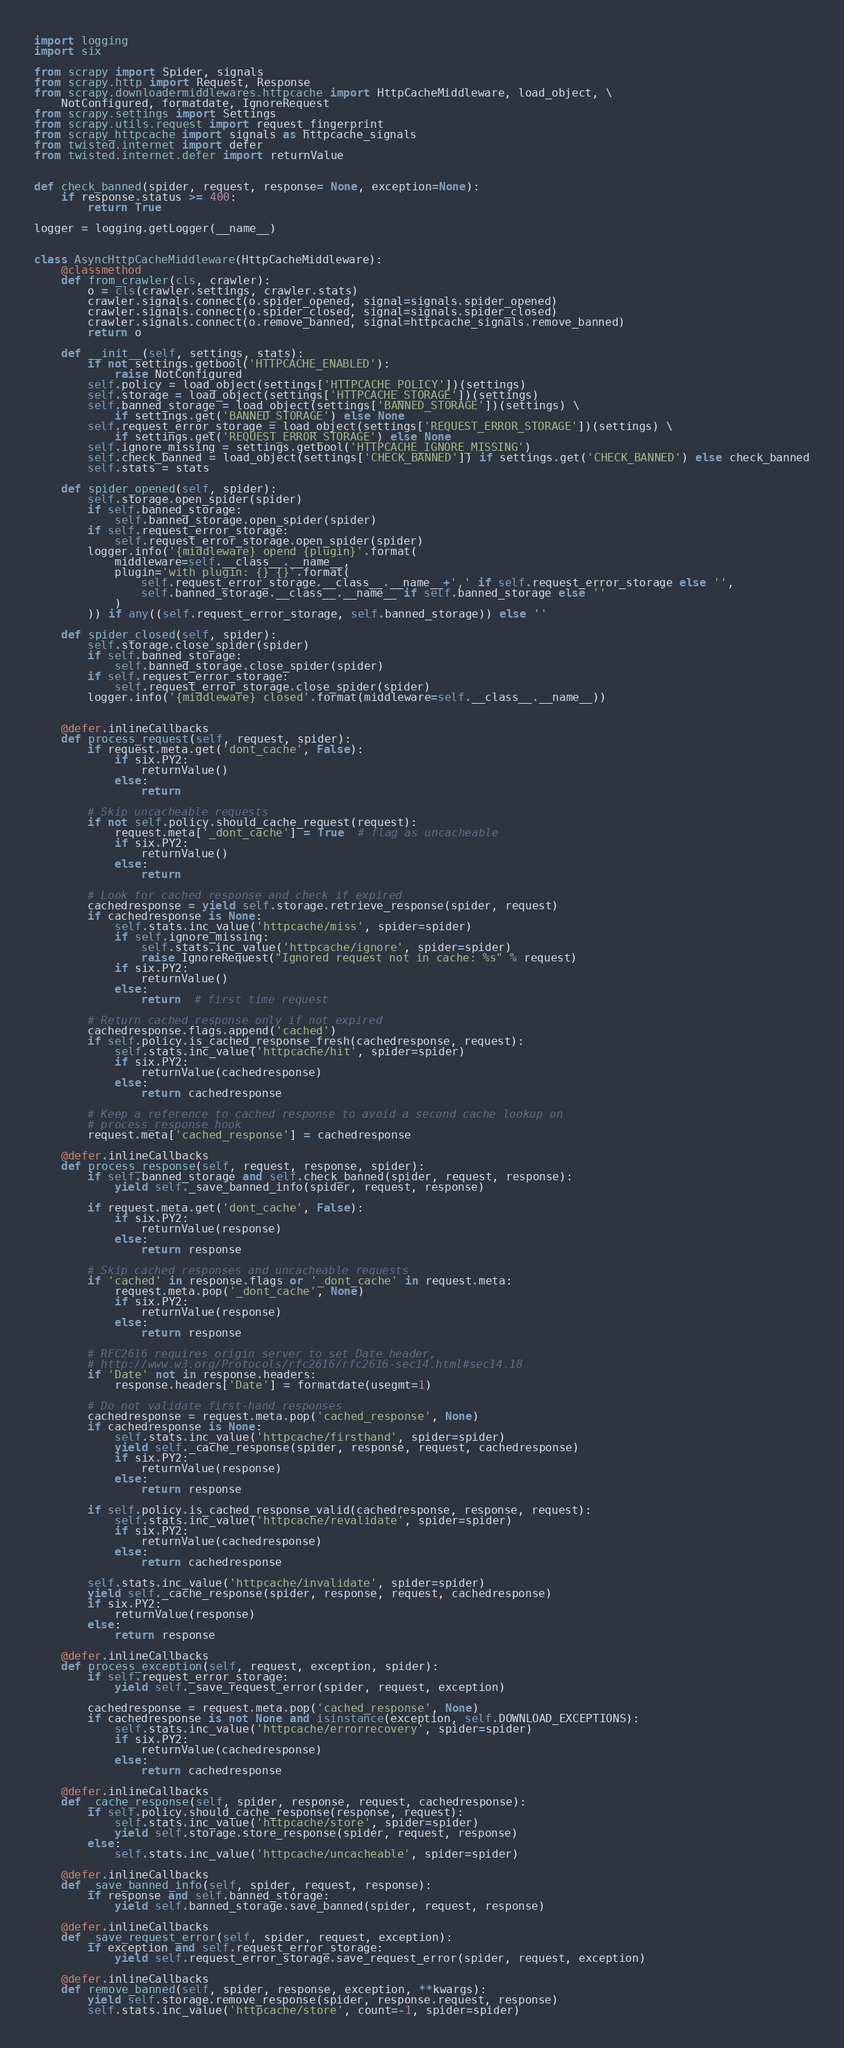Convert code to text. <code><loc_0><loc_0><loc_500><loc_500><_Python_>import logging
import six

from scrapy import Spider, signals
from scrapy.http import Request, Response
from scrapy.downloadermiddlewares.httpcache import HttpCacheMiddleware, load_object, \
    NotConfigured, formatdate, IgnoreRequest
from scrapy.settings import Settings
from scrapy.utils.request import request_fingerprint
from scrapy_httpcache import signals as httpcache_signals
from twisted.internet import defer
from twisted.internet.defer import returnValue


def check_banned(spider, request, response= None, exception=None):
    if response.status >= 400:
        return True

logger = logging.getLogger(__name__)


class AsyncHttpCacheMiddleware(HttpCacheMiddleware):
    @classmethod
    def from_crawler(cls, crawler):
        o = cls(crawler.settings, crawler.stats)
        crawler.signals.connect(o.spider_opened, signal=signals.spider_opened)
        crawler.signals.connect(o.spider_closed, signal=signals.spider_closed)
        crawler.signals.connect(o.remove_banned, signal=httpcache_signals.remove_banned)
        return o

    def __init__(self, settings, stats):
        if not settings.getbool('HTTPCACHE_ENABLED'):
            raise NotConfigured
        self.policy = load_object(settings['HTTPCACHE_POLICY'])(settings)
        self.storage = load_object(settings['HTTPCACHE_STORAGE'])(settings)
        self.banned_storage = load_object(settings['BANNED_STORAGE'])(settings) \
            if settings.get('BANNED_STORAGE') else None
        self.request_error_storage = load_object(settings['REQUEST_ERROR_STORAGE'])(settings) \
            if settings.get('REQUEST_ERROR_STORAGE') else None
        self.ignore_missing = settings.getbool('HTTPCACHE_IGNORE_MISSING')
        self.check_banned = load_object(settings['CHECK_BANNED']) if settings.get('CHECK_BANNED') else check_banned
        self.stats = stats

    def spider_opened(self, spider):
        self.storage.open_spider(spider)
        if self.banned_storage:
            self.banned_storage.open_spider(spider)
        if self.request_error_storage:
            self.request_error_storage.open_spider(spider)
        logger.info('{middleware} opend {plugin}'.format(
            middleware=self.__class__.__name__,
            plugin='with plugin: {} {}'.format(
                self.request_error_storage.__class__.__name__+',' if self.request_error_storage else '',
                self.banned_storage.__class__.__name__ if self.banned_storage else ''
            )
        )) if any((self.request_error_storage, self.banned_storage)) else ''

    def spider_closed(self, spider):
        self.storage.close_spider(spider)
        if self.banned_storage:
            self.banned_storage.close_spider(spider)
        if self.request_error_storage:
            self.request_error_storage.close_spider(spider)
        logger.info('{middleware} closed'.format(middleware=self.__class__.__name__))


    @defer.inlineCallbacks
    def process_request(self, request, spider):
        if request.meta.get('dont_cache', False):
            if six.PY2:
                returnValue()
            else:
                return

        # Skip uncacheable requests
        if not self.policy.should_cache_request(request):
            request.meta['_dont_cache'] = True  # flag as uncacheable
            if six.PY2:
                returnValue()
            else:
                return

        # Look for cached response and check if expired
        cachedresponse = yield self.storage.retrieve_response(spider, request)
        if cachedresponse is None:
            self.stats.inc_value('httpcache/miss', spider=spider)
            if self.ignore_missing:
                self.stats.inc_value('httpcache/ignore', spider=spider)
                raise IgnoreRequest("Ignored request not in cache: %s" % request)
            if six.PY2:
                returnValue()
            else:
                return  # first time request

        # Return cached response only if not expired
        cachedresponse.flags.append('cached')
        if self.policy.is_cached_response_fresh(cachedresponse, request):
            self.stats.inc_value('httpcache/hit', spider=spider)
            if six.PY2:
                returnValue(cachedresponse)
            else:
                return cachedresponse

        # Keep a reference to cached response to avoid a second cache lookup on
        # process_response hook
        request.meta['cached_response'] = cachedresponse

    @defer.inlineCallbacks
    def process_response(self, request, response, spider):
        if self.banned_storage and self.check_banned(spider, request, response):
            yield self._save_banned_info(spider, request, response)

        if request.meta.get('dont_cache', False):
            if six.PY2:
                returnValue(response)
            else:
                return response

        # Skip cached responses and uncacheable requests
        if 'cached' in response.flags or '_dont_cache' in request.meta:
            request.meta.pop('_dont_cache', None)
            if six.PY2:
                returnValue(response)
            else:
                return response

        # RFC2616 requires origin server to set Date header,
        # http://www.w3.org/Protocols/rfc2616/rfc2616-sec14.html#sec14.18
        if 'Date' not in response.headers:
            response.headers['Date'] = formatdate(usegmt=1)

        # Do not validate first-hand responses
        cachedresponse = request.meta.pop('cached_response', None)
        if cachedresponse is None:
            self.stats.inc_value('httpcache/firsthand', spider=spider)
            yield self._cache_response(spider, response, request, cachedresponse)
            if six.PY2:
                returnValue(response)
            else:
                return response

        if self.policy.is_cached_response_valid(cachedresponse, response, request):
            self.stats.inc_value('httpcache/revalidate', spider=spider)
            if six.PY2:
                returnValue(cachedresponse)
            else:
                return cachedresponse

        self.stats.inc_value('httpcache/invalidate', spider=spider)
        yield self._cache_response(spider, response, request, cachedresponse)
        if six.PY2:
            returnValue(response)
        else:
            return response

    @defer.inlineCallbacks
    def process_exception(self, request, exception, spider):
        if self.request_error_storage:
            yield self._save_request_error(spider, request, exception)

        cachedresponse = request.meta.pop('cached_response', None)
        if cachedresponse is not None and isinstance(exception, self.DOWNLOAD_EXCEPTIONS):
            self.stats.inc_value('httpcache/errorrecovery', spider=spider)
            if six.PY2:
                returnValue(cachedresponse)
            else:
                return cachedresponse

    @defer.inlineCallbacks
    def _cache_response(self, spider, response, request, cachedresponse):
        if self.policy.should_cache_response(response, request):
            self.stats.inc_value('httpcache/store', spider=spider)
            yield self.storage.store_response(spider, request, response)
        else:
            self.stats.inc_value('httpcache/uncacheable', spider=spider)

    @defer.inlineCallbacks
    def _save_banned_info(self, spider, request, response):
        if response and self.banned_storage:
            yield self.banned_storage.save_banned(spider, request, response)

    @defer.inlineCallbacks
    def _save_request_error(self, spider, request, exception):
        if exception and self.request_error_storage:
            yield self.request_error_storage.save_request_error(spider, request, exception)

    @defer.inlineCallbacks
    def remove_banned(self, spider, response, exception, **kwargs):
        yield self.storage.remove_response(spider, response.request, response)
        self.stats.inc_value('httpcache/store', count=-1, spider=spider)</code> 